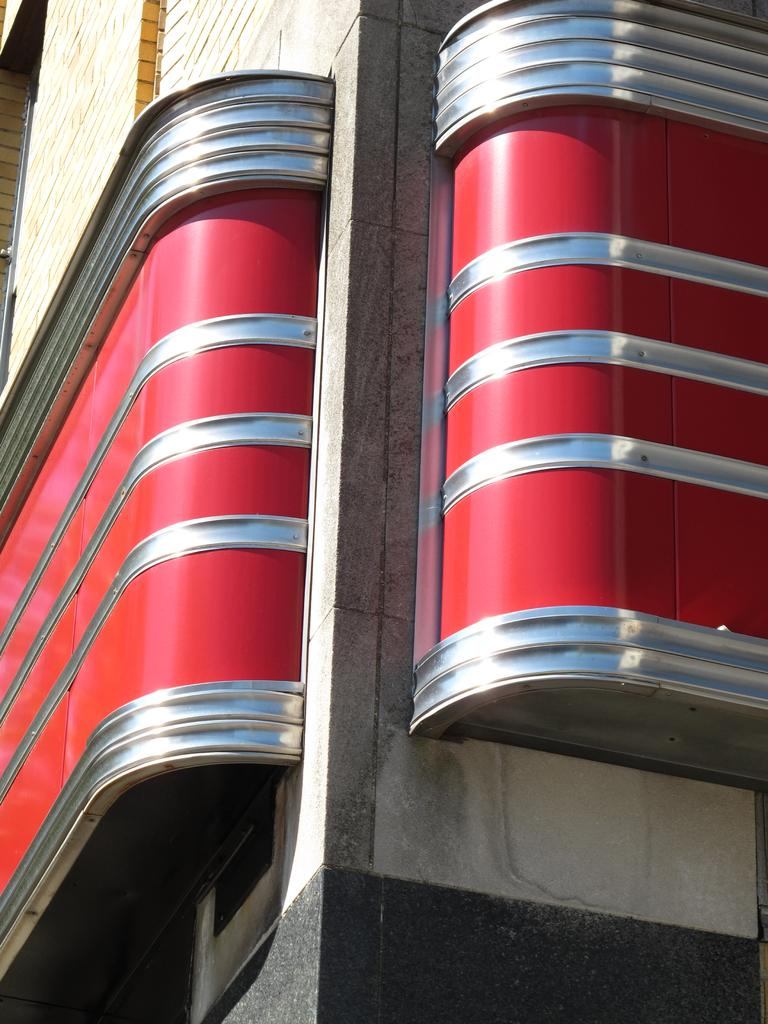What is the main subject of the image? The main subject of the image is a building under construction. What can be seen on the wall of the building? There is an architecture design on the wall of the building. How many buns are present on the construction site in the image? There are no buns present in the image; it shows a building under construction and an architecture design on the wall. 